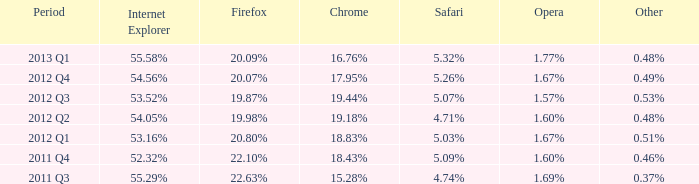87% as the firefox? 1.57%. 